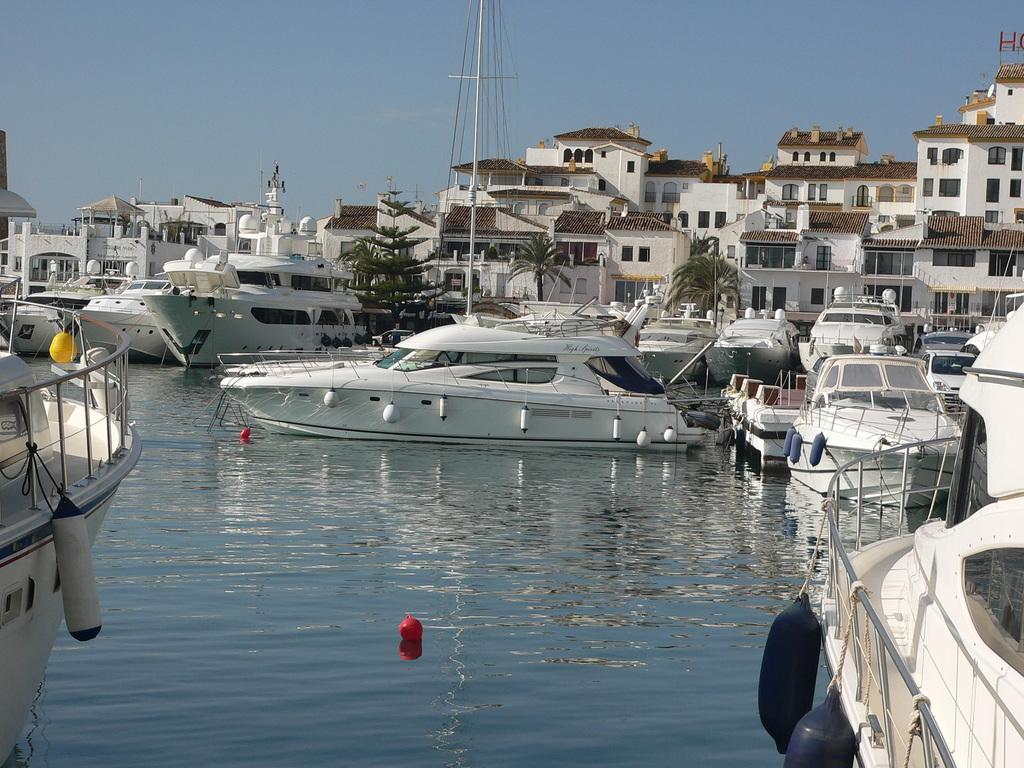What body of water is present in the image? There is a river in the image. What is happening on the river? There are ships sailing on the river. What can be seen in the distance in the image? There are beautiful houses visible in the background. What type of prose can be seen on the plate in the image? There is no plate or prose present in the image; it features a river with ships sailing on it and beautiful houses in the background. 